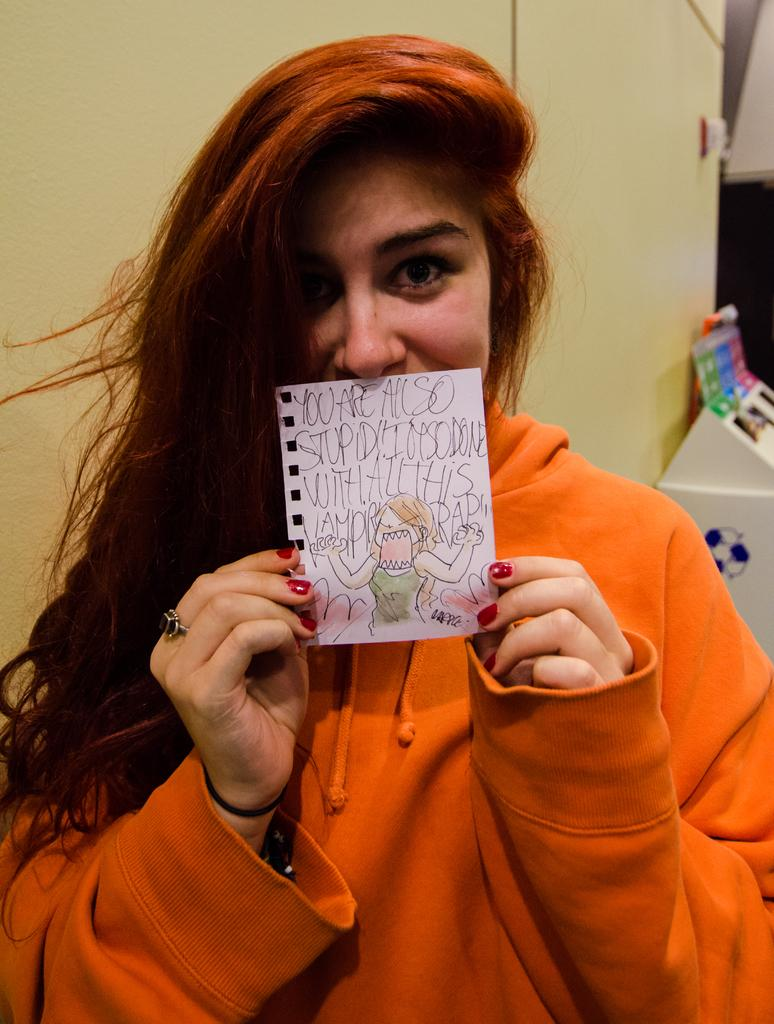Who is present in the image? There is a woman in the image. What is the woman holding in the image? The woman is holding a paper. What can be seen on the paper? The paper has text on it. What type of coast can be seen in the image? There is no coast present in the image; it features a woman holding a paper with text on it. What is the woman's occupation in the image? The image does not provide information about the woman's occupation, so it cannot be determined from the image. 